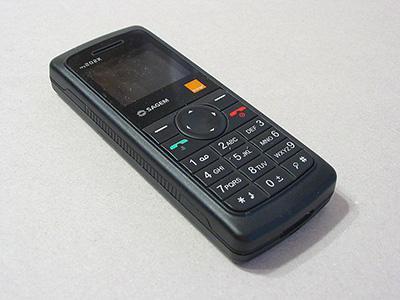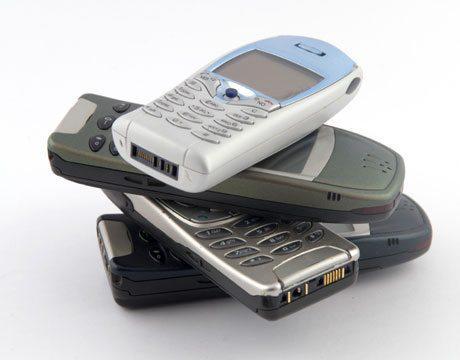The first image is the image on the left, the second image is the image on the right. Examine the images to the left and right. Is the description "The right image contains a stack of four phones, with the phones stacked in a staggered fashion instead of aligned." accurate? Answer yes or no. Yes. The first image is the image on the left, the second image is the image on the right. Considering the images on both sides, is "At least four phones are stacked on top of each other in at least one of the pictures." valid? Answer yes or no. Yes. 